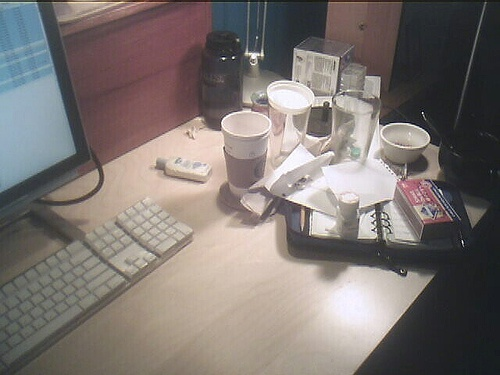Describe the objects in this image and their specific colors. I can see keyboard in blue, gray, and darkgray tones, tv in blue, darkgray, gray, and black tones, bottle in blue, gray, and black tones, cup in blue, darkgray, gray, and lightgray tones, and cup in blue, lightgray, and darkgray tones in this image. 